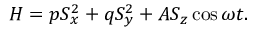Convert formula to latex. <formula><loc_0><loc_0><loc_500><loc_500>H = p S _ { x } ^ { 2 } + q S _ { y } ^ { 2 } + A S _ { z } \cos \omega t .</formula> 